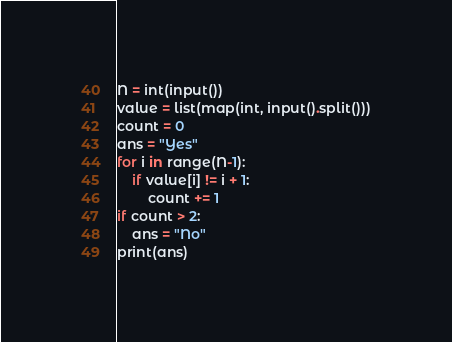<code> <loc_0><loc_0><loc_500><loc_500><_Python_>N = int(input())
value = list(map(int, input().split()))
count = 0
ans = "Yes"
for i in range(N-1):
    if value[i] != i + 1:
        count += 1
if count > 2:
    ans = "No"
print(ans)</code> 